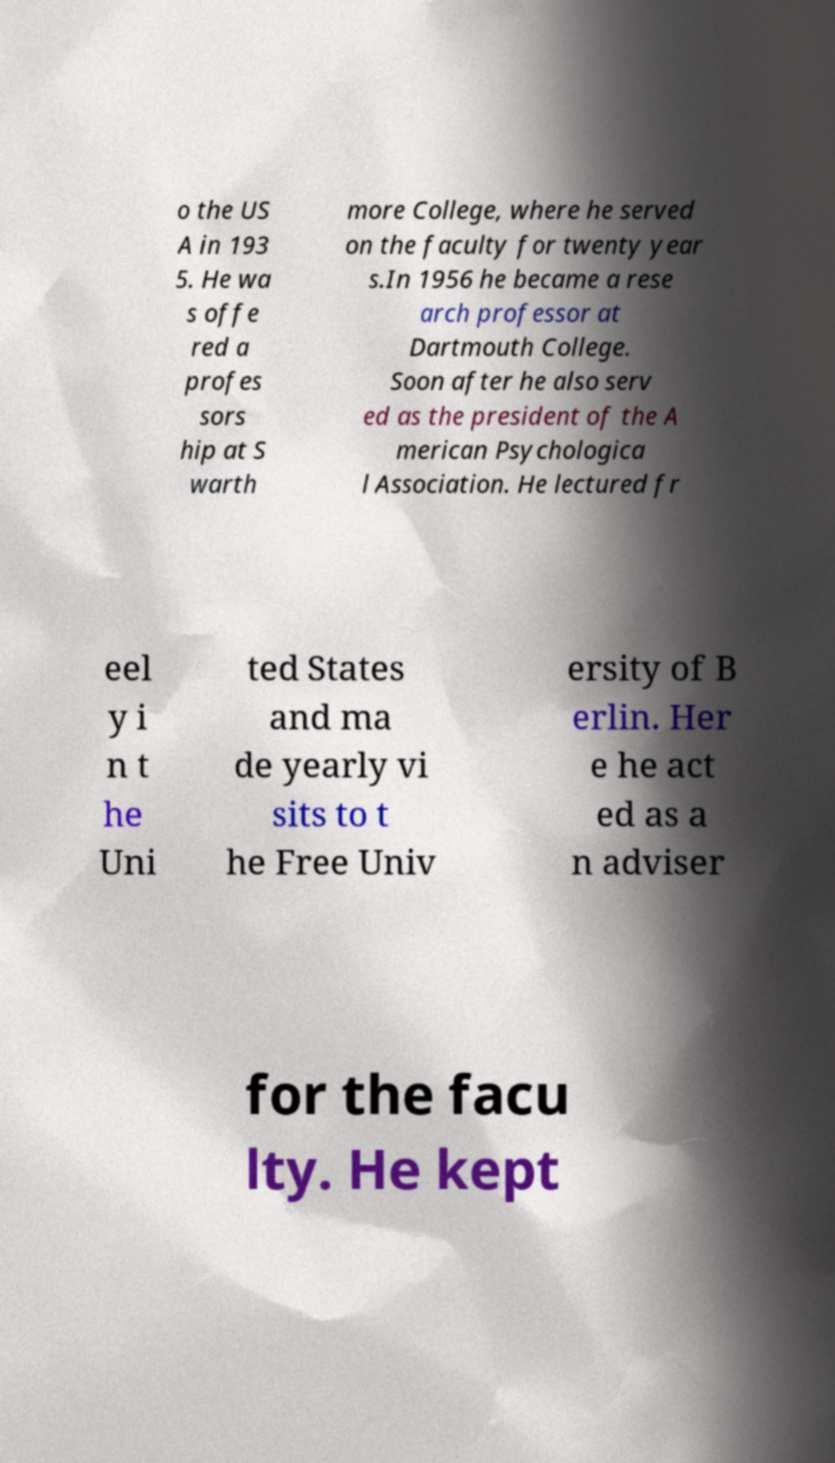Can you accurately transcribe the text from the provided image for me? o the US A in 193 5. He wa s offe red a profes sors hip at S warth more College, where he served on the faculty for twenty year s.In 1956 he became a rese arch professor at Dartmouth College. Soon after he also serv ed as the president of the A merican Psychologica l Association. He lectured fr eel y i n t he Uni ted States and ma de yearly vi sits to t he Free Univ ersity of B erlin. Her e he act ed as a n adviser for the facu lty. He kept 